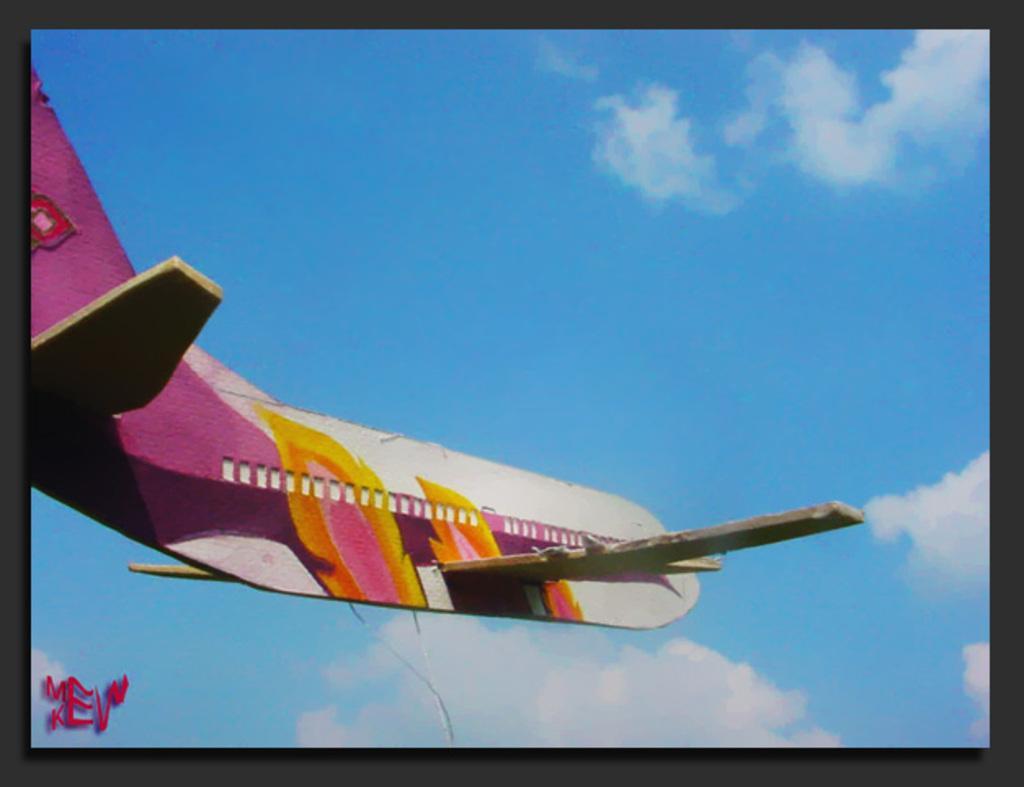Could you give a brief overview of what you see in this image? In this image I can see an aircraft which is in pink, white and yellow color. It is in the air. In the background I can see the clouds and the sky. And this is a cardboard sheet. I can see the black boundaries. 